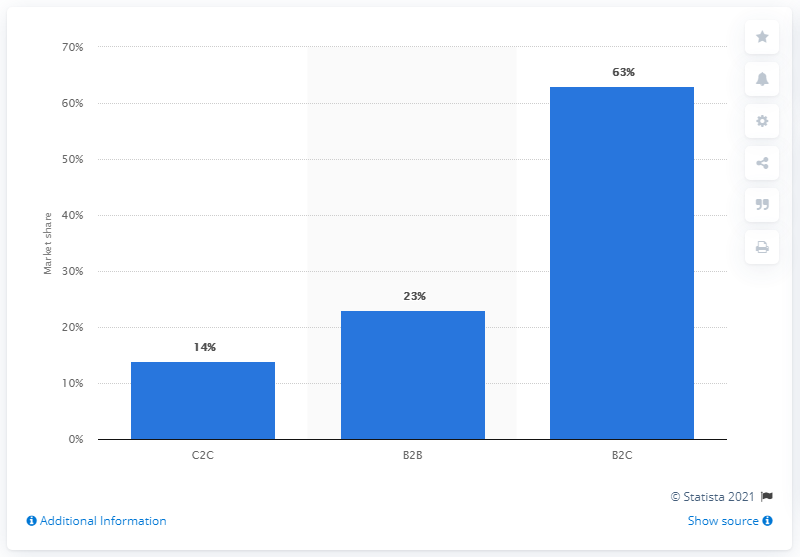Highlight a few significant elements in this photo. In 2021, 63% of same-day package deliveries were for business-to-consumer transactions. 